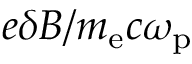Convert formula to latex. <formula><loc_0><loc_0><loc_500><loc_500>e \delta B / m _ { e } c \omega _ { p }</formula> 